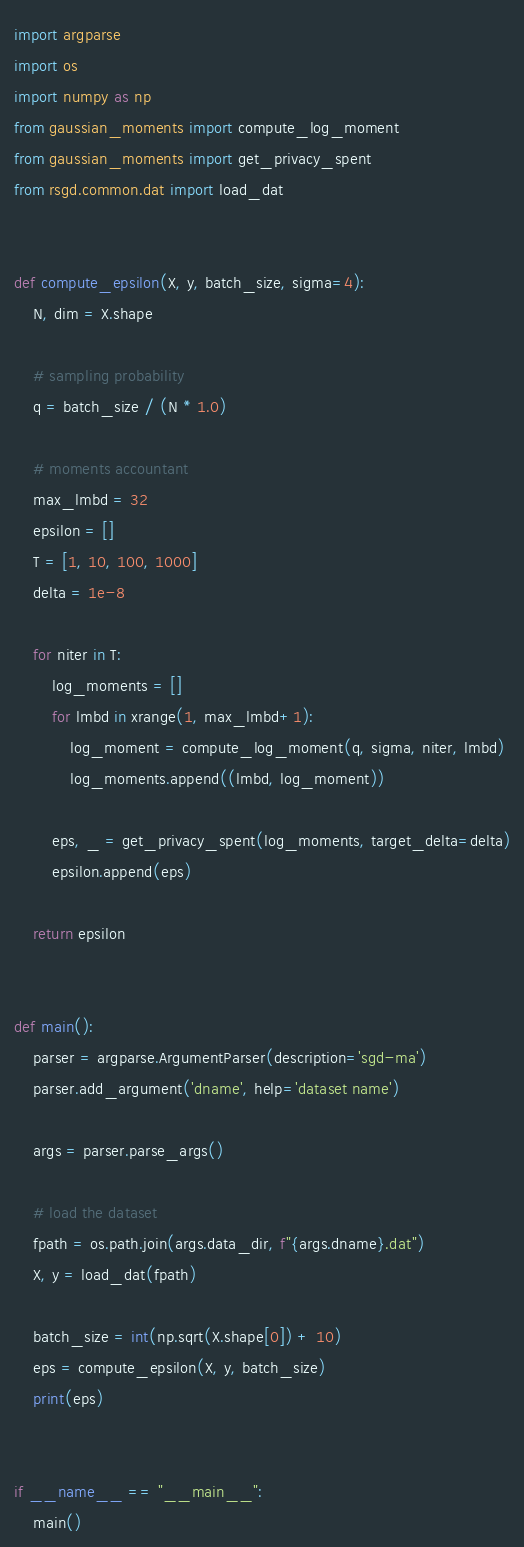<code> <loc_0><loc_0><loc_500><loc_500><_Python_>import argparse
import os
import numpy as np
from gaussian_moments import compute_log_moment
from gaussian_moments import get_privacy_spent
from rsgd.common.dat import load_dat


def compute_epsilon(X, y, batch_size, sigma=4):
    N, dim = X.shape

    # sampling probability
    q = batch_size / (N * 1.0)

    # moments accountant
    max_lmbd = 32
    epsilon = []
    T = [1, 10, 100, 1000]
    delta = 1e-8

    for niter in T:
        log_moments = []
        for lmbd in xrange(1, max_lmbd+1):
            log_moment = compute_log_moment(q, sigma, niter, lmbd)
            log_moments.append((lmbd, log_moment))

        eps, _ = get_privacy_spent(log_moments, target_delta=delta)
        epsilon.append(eps)

    return epsilon


def main():
    parser = argparse.ArgumentParser(description='sgd-ma')
    parser.add_argument('dname', help='dataset name')

    args = parser.parse_args()

    # load the dataset
    fpath = os.path.join(args.data_dir, f"{args.dname}.dat")
    X, y = load_dat(fpath)

    batch_size = int(np.sqrt(X.shape[0]) + 10)
    eps = compute_epsilon(X, y, batch_size)
    print(eps)


if __name__ == "__main__":
    main()
</code> 